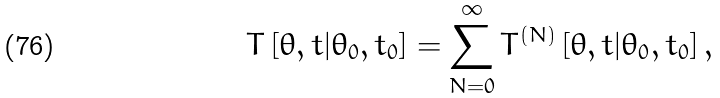<formula> <loc_0><loc_0><loc_500><loc_500>T \left [ \theta , t | \theta _ { 0 } , t _ { 0 } \right ] = \sum _ { N = 0 } ^ { \infty } T ^ { ( N ) } \left [ \theta , t | \theta _ { 0 } , t _ { 0 } \right ] ,</formula> 